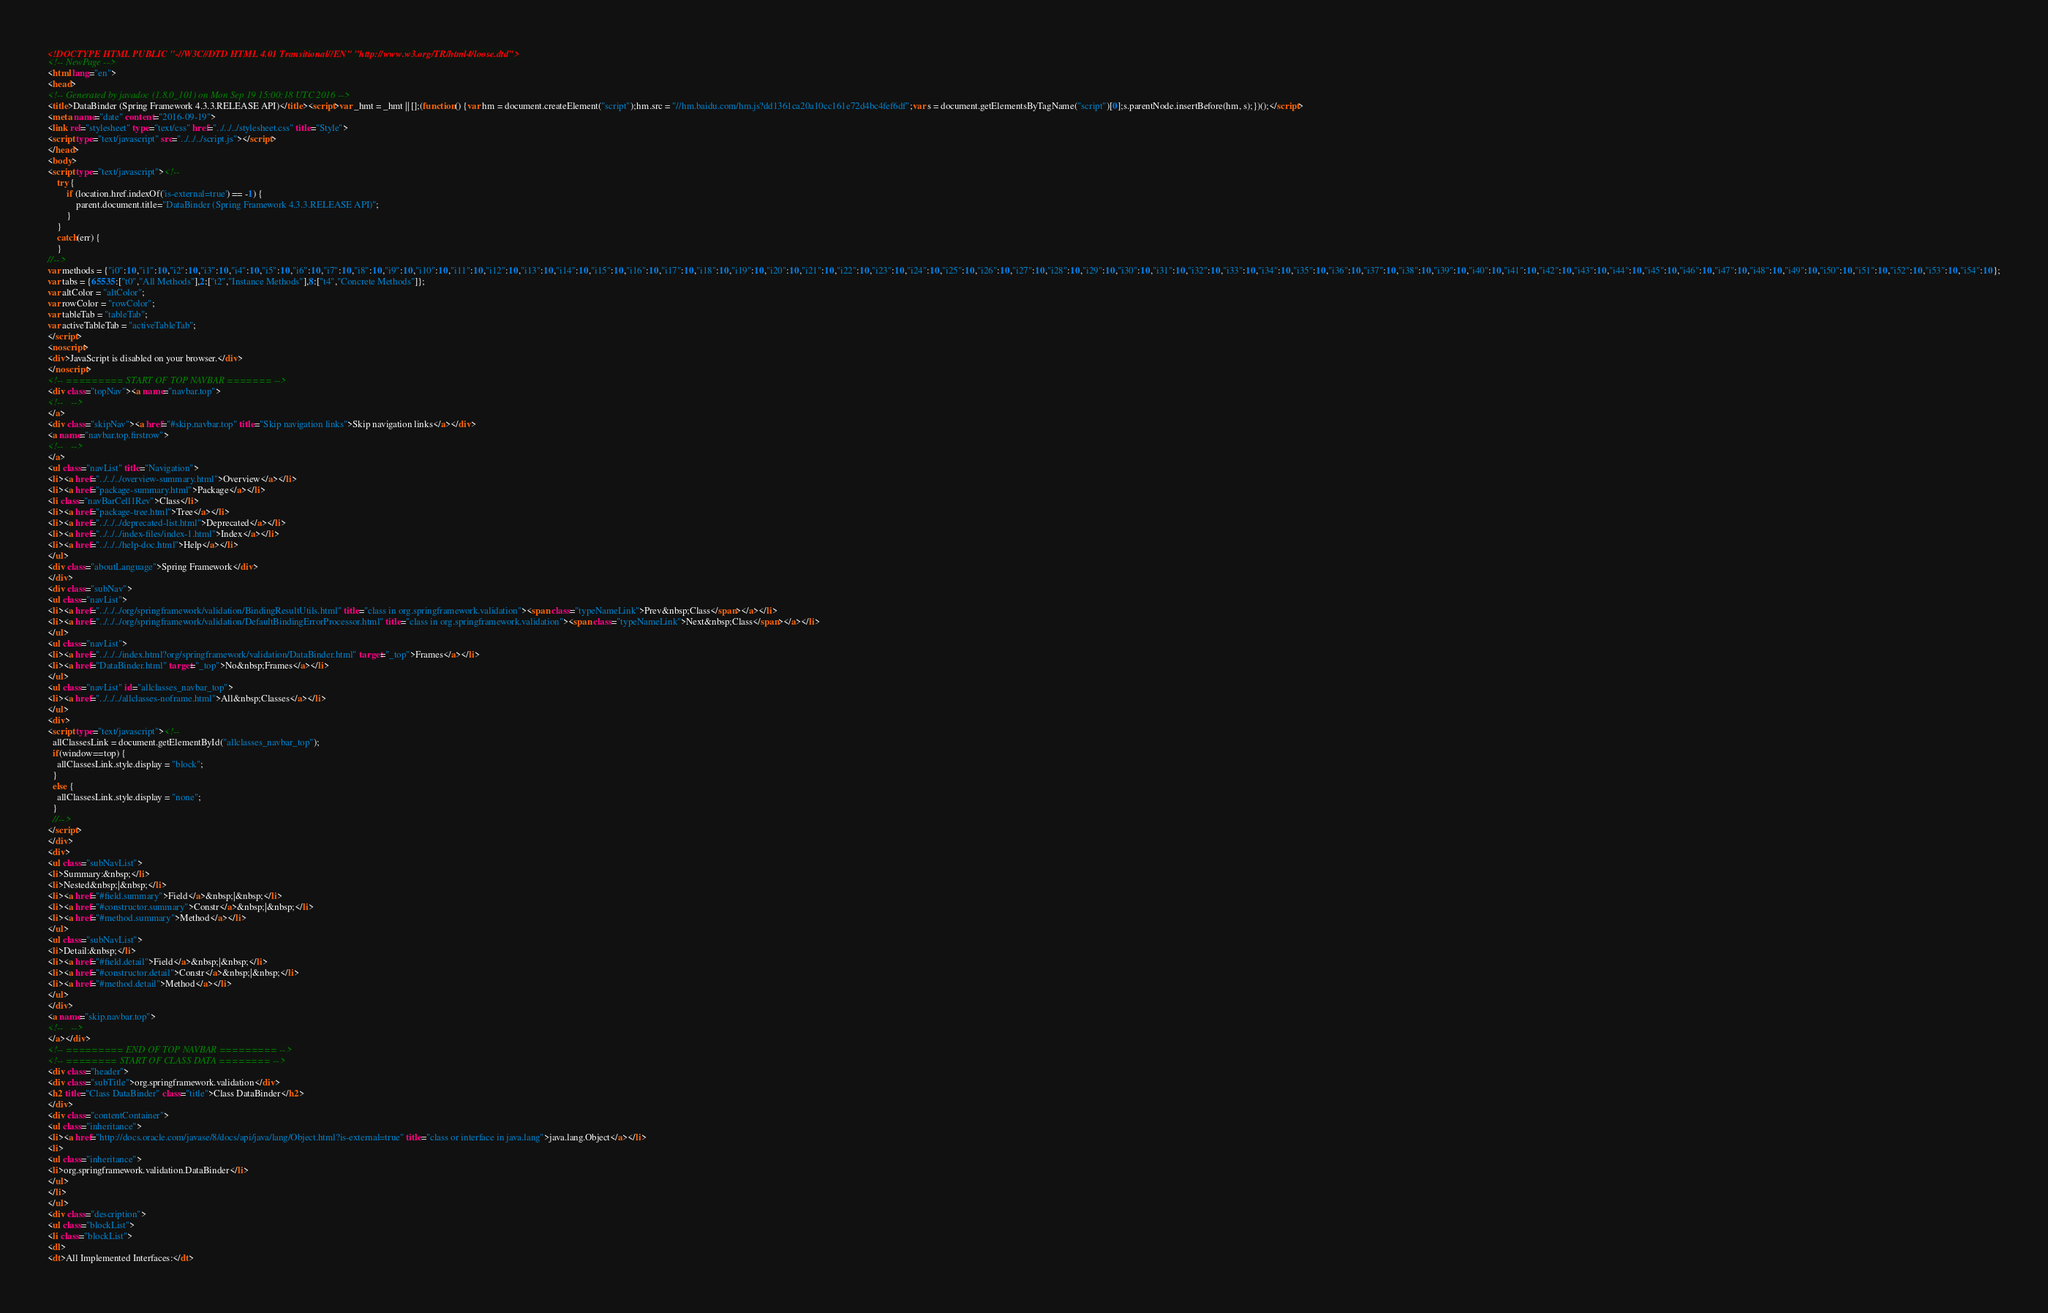<code> <loc_0><loc_0><loc_500><loc_500><_HTML_><!DOCTYPE HTML PUBLIC "-//W3C//DTD HTML 4.01 Transitional//EN" "http://www.w3.org/TR/html4/loose.dtd">
<!-- NewPage -->
<html lang="en">
<head>
<!-- Generated by javadoc (1.8.0_101) on Mon Sep 19 15:00:18 UTC 2016 -->
<title>DataBinder (Spring Framework 4.3.3.RELEASE API)</title><script>var _hmt = _hmt || [];(function() {var hm = document.createElement("script");hm.src = "//hm.baidu.com/hm.js?dd1361ca20a10cc161e72d4bc4fef6df";var s = document.getElementsByTagName("script")[0];s.parentNode.insertBefore(hm, s);})();</script>
<meta name="date" content="2016-09-19">
<link rel="stylesheet" type="text/css" href="../../../stylesheet.css" title="Style">
<script type="text/javascript" src="../../../script.js"></script>
</head>
<body>
<script type="text/javascript"><!--
    try {
        if (location.href.indexOf('is-external=true') == -1) {
            parent.document.title="DataBinder (Spring Framework 4.3.3.RELEASE API)";
        }
    }
    catch(err) {
    }
//-->
var methods = {"i0":10,"i1":10,"i2":10,"i3":10,"i4":10,"i5":10,"i6":10,"i7":10,"i8":10,"i9":10,"i10":10,"i11":10,"i12":10,"i13":10,"i14":10,"i15":10,"i16":10,"i17":10,"i18":10,"i19":10,"i20":10,"i21":10,"i22":10,"i23":10,"i24":10,"i25":10,"i26":10,"i27":10,"i28":10,"i29":10,"i30":10,"i31":10,"i32":10,"i33":10,"i34":10,"i35":10,"i36":10,"i37":10,"i38":10,"i39":10,"i40":10,"i41":10,"i42":10,"i43":10,"i44":10,"i45":10,"i46":10,"i47":10,"i48":10,"i49":10,"i50":10,"i51":10,"i52":10,"i53":10,"i54":10};
var tabs = {65535:["t0","All Methods"],2:["t2","Instance Methods"],8:["t4","Concrete Methods"]};
var altColor = "altColor";
var rowColor = "rowColor";
var tableTab = "tableTab";
var activeTableTab = "activeTableTab";
</script>
<noscript>
<div>JavaScript is disabled on your browser.</div>
</noscript>
<!-- ========= START OF TOP NAVBAR ======= -->
<div class="topNav"><a name="navbar.top">
<!--   -->
</a>
<div class="skipNav"><a href="#skip.navbar.top" title="Skip navigation links">Skip navigation links</a></div>
<a name="navbar.top.firstrow">
<!--   -->
</a>
<ul class="navList" title="Navigation">
<li><a href="../../../overview-summary.html">Overview</a></li>
<li><a href="package-summary.html">Package</a></li>
<li class="navBarCell1Rev">Class</li>
<li><a href="package-tree.html">Tree</a></li>
<li><a href="../../../deprecated-list.html">Deprecated</a></li>
<li><a href="../../../index-files/index-1.html">Index</a></li>
<li><a href="../../../help-doc.html">Help</a></li>
</ul>
<div class="aboutLanguage">Spring Framework</div>
</div>
<div class="subNav">
<ul class="navList">
<li><a href="../../../org/springframework/validation/BindingResultUtils.html" title="class in org.springframework.validation"><span class="typeNameLink">Prev&nbsp;Class</span></a></li>
<li><a href="../../../org/springframework/validation/DefaultBindingErrorProcessor.html" title="class in org.springframework.validation"><span class="typeNameLink">Next&nbsp;Class</span></a></li>
</ul>
<ul class="navList">
<li><a href="../../../index.html?org/springframework/validation/DataBinder.html" target="_top">Frames</a></li>
<li><a href="DataBinder.html" target="_top">No&nbsp;Frames</a></li>
</ul>
<ul class="navList" id="allclasses_navbar_top">
<li><a href="../../../allclasses-noframe.html">All&nbsp;Classes</a></li>
</ul>
<div>
<script type="text/javascript"><!--
  allClassesLink = document.getElementById("allclasses_navbar_top");
  if(window==top) {
    allClassesLink.style.display = "block";
  }
  else {
    allClassesLink.style.display = "none";
  }
  //-->
</script>
</div>
<div>
<ul class="subNavList">
<li>Summary:&nbsp;</li>
<li>Nested&nbsp;|&nbsp;</li>
<li><a href="#field.summary">Field</a>&nbsp;|&nbsp;</li>
<li><a href="#constructor.summary">Constr</a>&nbsp;|&nbsp;</li>
<li><a href="#method.summary">Method</a></li>
</ul>
<ul class="subNavList">
<li>Detail:&nbsp;</li>
<li><a href="#field.detail">Field</a>&nbsp;|&nbsp;</li>
<li><a href="#constructor.detail">Constr</a>&nbsp;|&nbsp;</li>
<li><a href="#method.detail">Method</a></li>
</ul>
</div>
<a name="skip.navbar.top">
<!--   -->
</a></div>
<!-- ========= END OF TOP NAVBAR ========= -->
<!-- ======== START OF CLASS DATA ======== -->
<div class="header">
<div class="subTitle">org.springframework.validation</div>
<h2 title="Class DataBinder" class="title">Class DataBinder</h2>
</div>
<div class="contentContainer">
<ul class="inheritance">
<li><a href="http://docs.oracle.com/javase/8/docs/api/java/lang/Object.html?is-external=true" title="class or interface in java.lang">java.lang.Object</a></li>
<li>
<ul class="inheritance">
<li>org.springframework.validation.DataBinder</li>
</ul>
</li>
</ul>
<div class="description">
<ul class="blockList">
<li class="blockList">
<dl>
<dt>All Implemented Interfaces:</dt></code> 